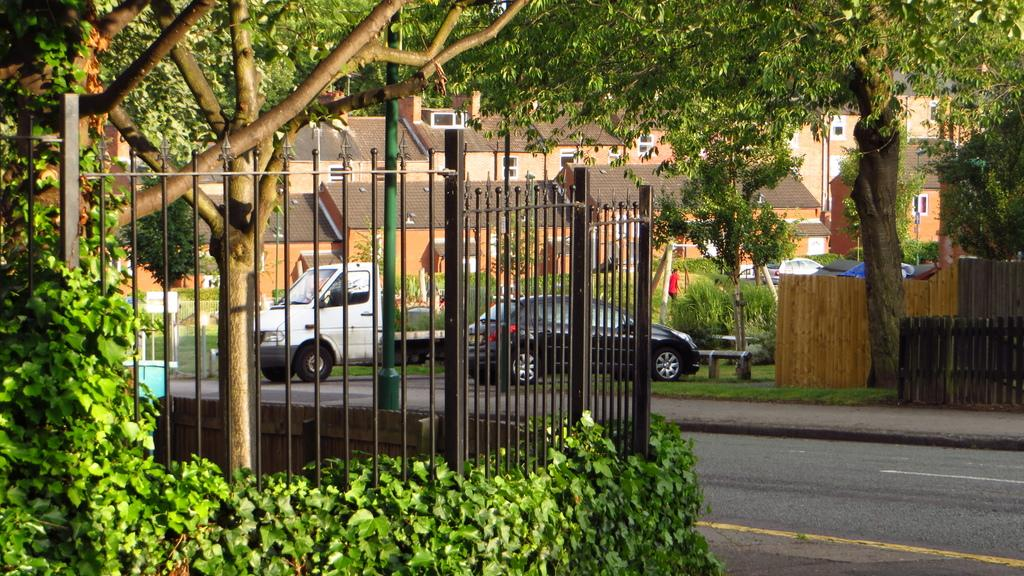What is located in the foreground of the image? There is a grille and plants in the foreground of the image. What can be seen in the background of the image? There are buildings, trees, a fence, a person, and vehicles on the road in the background of the image. Can you tell me how many matches the person in the image is holding? There is no mention of matches or any similar objects in the image. The person in the background is not holding any matches. What type of beast can be seen interacting with the person in the image? There is no beast present in the image; only the person, buildings, trees, fence, and vehicles on the road are visible. 